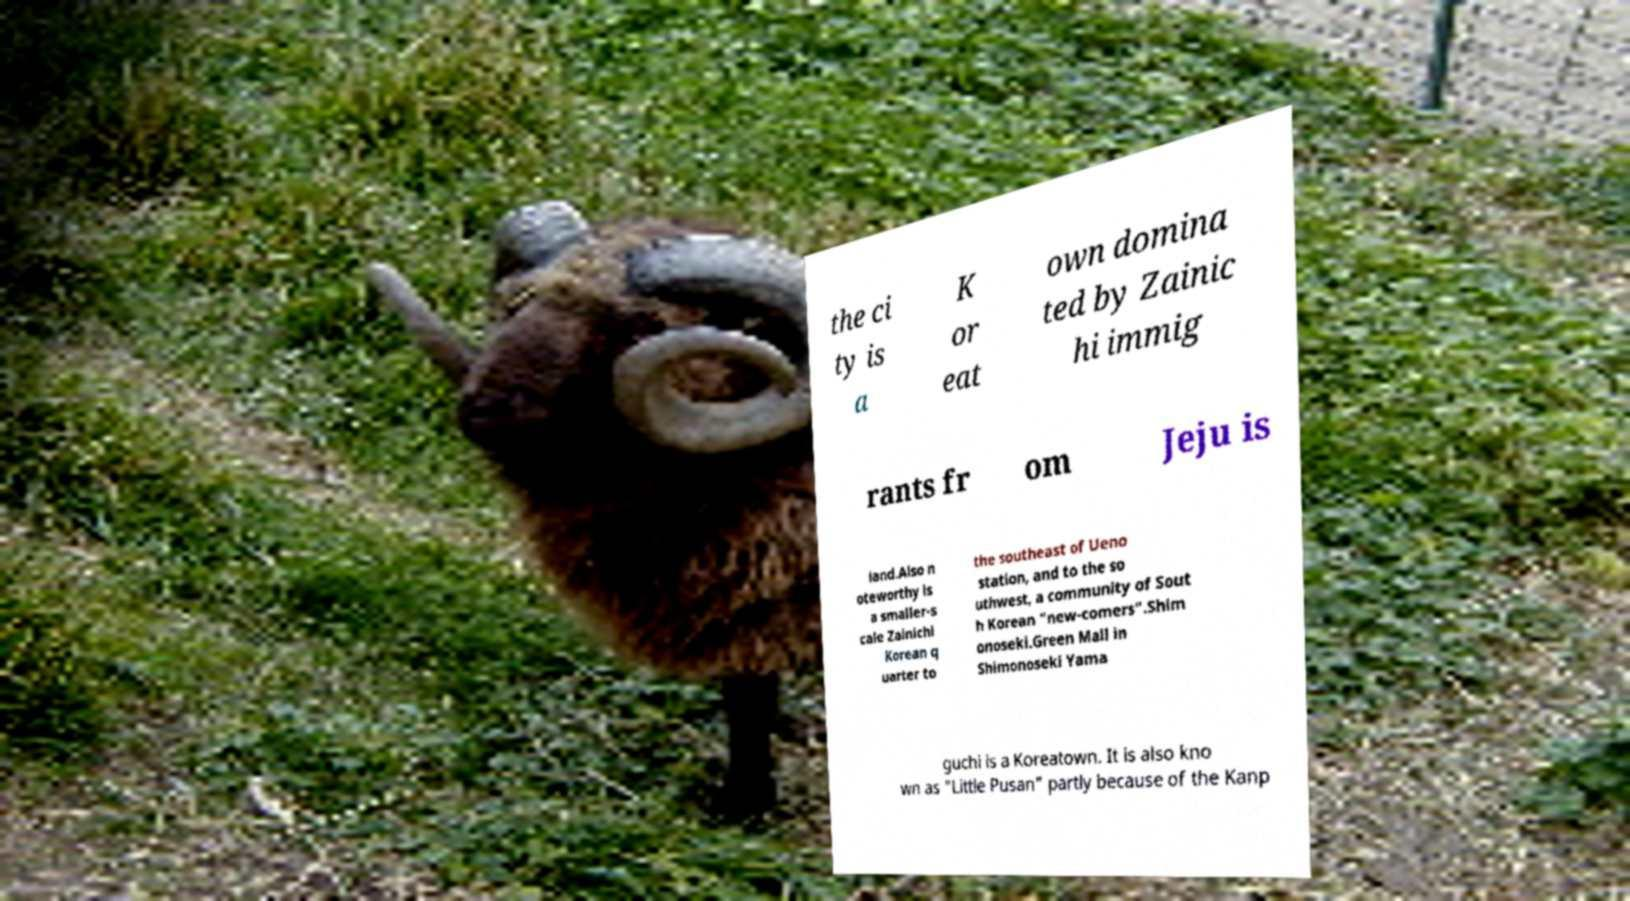There's text embedded in this image that I need extracted. Can you transcribe it verbatim? the ci ty is a K or eat own domina ted by Zainic hi immig rants fr om Jeju is land.Also n oteworthy is a smaller-s cale Zainichi Korean q uarter to the southeast of Ueno station, and to the so uthwest, a community of Sout h Korean "new-comers".Shim onoseki.Green Mall in Shimonoseki Yama guchi is a Koreatown. It is also kno wn as "Little Pusan" partly because of the Kanp 